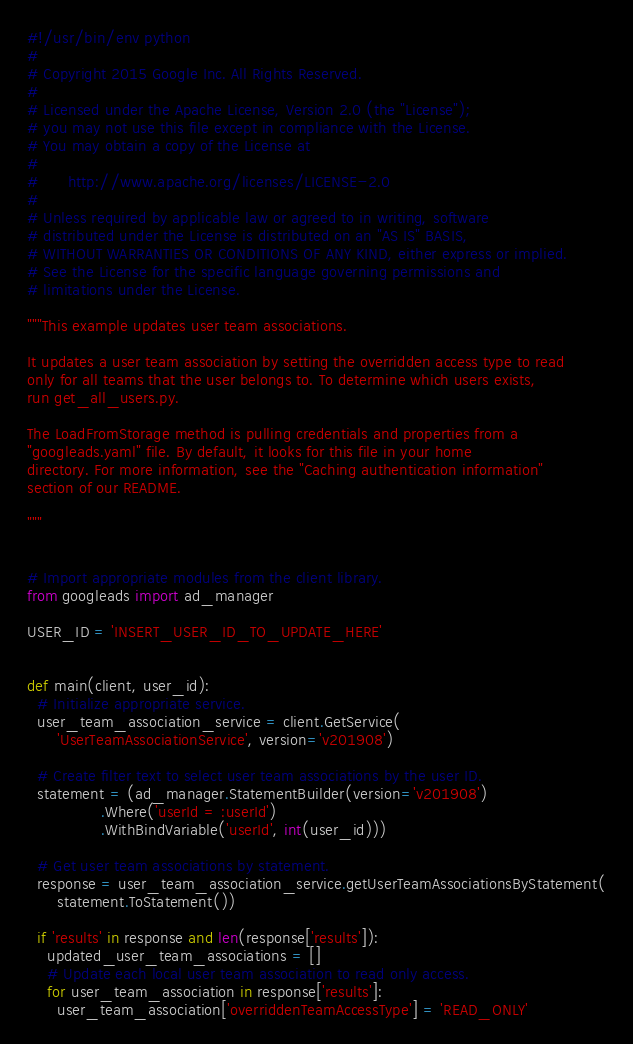<code> <loc_0><loc_0><loc_500><loc_500><_Python_>#!/usr/bin/env python
#
# Copyright 2015 Google Inc. All Rights Reserved.
#
# Licensed under the Apache License, Version 2.0 (the "License");
# you may not use this file except in compliance with the License.
# You may obtain a copy of the License at
#
#      http://www.apache.org/licenses/LICENSE-2.0
#
# Unless required by applicable law or agreed to in writing, software
# distributed under the License is distributed on an "AS IS" BASIS,
# WITHOUT WARRANTIES OR CONDITIONS OF ANY KIND, either express or implied.
# See the License for the specific language governing permissions and
# limitations under the License.

"""This example updates user team associations.

It updates a user team association by setting the overridden access type to read
only for all teams that the user belongs to. To determine which users exists,
run get_all_users.py.

The LoadFromStorage method is pulling credentials and properties from a
"googleads.yaml" file. By default, it looks for this file in your home
directory. For more information, see the "Caching authentication information"
section of our README.

"""


# Import appropriate modules from the client library.
from googleads import ad_manager

USER_ID = 'INSERT_USER_ID_TO_UPDATE_HERE'


def main(client, user_id):
  # Initialize appropriate service.
  user_team_association_service = client.GetService(
      'UserTeamAssociationService', version='v201908')

  # Create filter text to select user team associations by the user ID.
  statement = (ad_manager.StatementBuilder(version='v201908')
               .Where('userId = :userId')
               .WithBindVariable('userId', int(user_id)))

  # Get user team associations by statement.
  response = user_team_association_service.getUserTeamAssociationsByStatement(
      statement.ToStatement())

  if 'results' in response and len(response['results']):
    updated_user_team_associations = []
    # Update each local user team association to read only access.
    for user_team_association in response['results']:
      user_team_association['overriddenTeamAccessType'] = 'READ_ONLY'</code> 